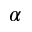<formula> <loc_0><loc_0><loc_500><loc_500>\alpha</formula> 